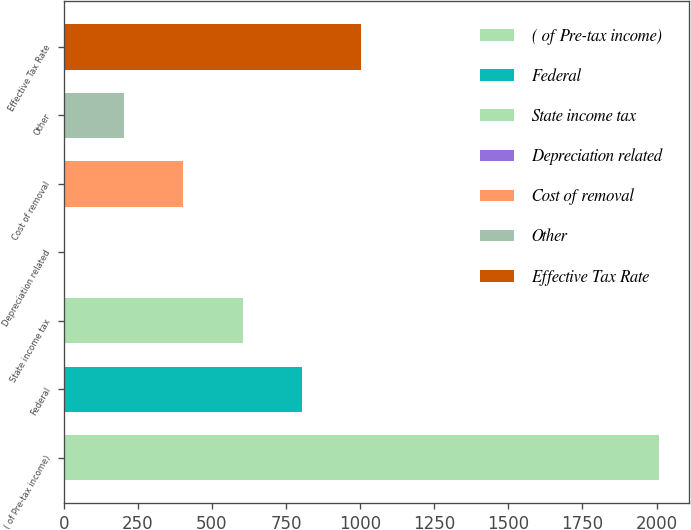Convert chart. <chart><loc_0><loc_0><loc_500><loc_500><bar_chart><fcel>( of Pre-tax income)<fcel>Federal<fcel>State income tax<fcel>Depreciation related<fcel>Cost of removal<fcel>Other<fcel>Effective Tax Rate<nl><fcel>2008<fcel>803.8<fcel>603.1<fcel>1<fcel>402.4<fcel>201.7<fcel>1004.5<nl></chart> 